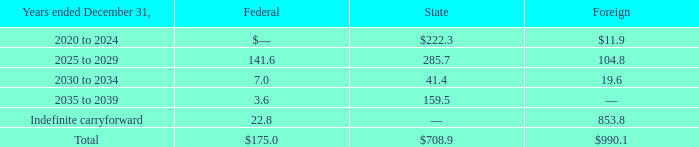AMERICAN TOWER CORPORATION AND SUBSIDIARIES
NOTES TO CONSOLIDATED FINANCIAL STATEMENTS
(Tabular amounts in millions, unless otherwise disclosed)
At December 31, 2019, the Company had net federal, state and foreign operating loss carryforwards available to reduce future taxable income. If not utilized, the Company’s NOLs expire as follows:
What was the company's Federal NOLs expiring in 2025 to 2029?
Answer scale should be: million. 141.6. What was the company's State NOLs expiring in 2020 to 2024?
Answer scale should be: million. $222.3. What was the company's Foreign NOLs expiring in 2030 to 2034?
Answer scale should be: million. 19.6. What is the difference between Federal and State NOLs in the period 2025 to 2029?
Answer scale should be: million. 285.7-141.6
Answer: 144.1. What was the Federal NOL as a ratio of Foreign NOL in the period 2030 to 2034?
Answer scale should be: percent. 7.0/19.6
Answer: 0.36. What is the sum of the company's total NOLs?
Answer scale should be: million. $175.0+$708.9+$990.1
Answer: 1874. 